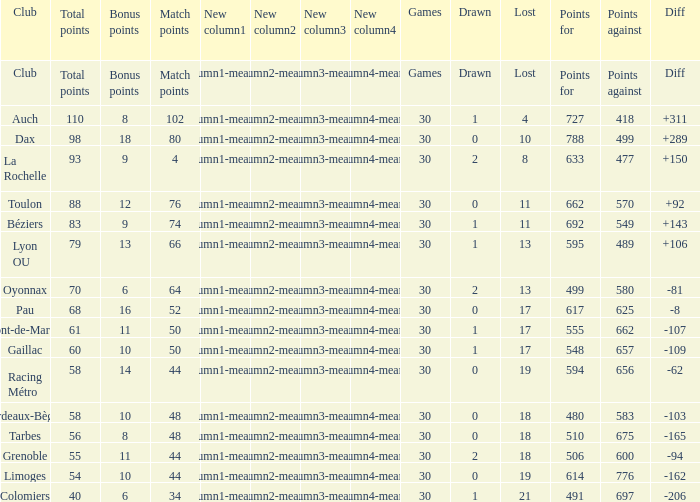What is the number of games for a club that has a value of 595 for points for? 30.0. 